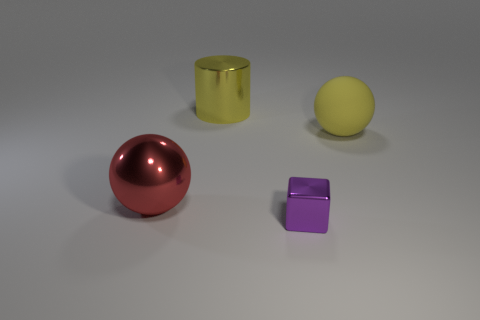Is there any other thing that is the same shape as the tiny purple thing?
Provide a succinct answer. No. What number of other objects are the same shape as the red metal thing?
Your answer should be compact. 1. Is there any other thing that has the same material as the small object?
Provide a succinct answer. Yes. The big object that is left of the small shiny block and in front of the cylinder is made of what material?
Your answer should be very brief. Metal. There is a small thing that is made of the same material as the big yellow cylinder; what shape is it?
Provide a succinct answer. Cube. Is there anything else that has the same color as the tiny cube?
Your answer should be compact. No. Is the number of large red spheres in front of the red thing greater than the number of metallic spheres?
Offer a terse response. No. What is the material of the red ball?
Your answer should be compact. Metal. What number of matte things have the same size as the purple block?
Ensure brevity in your answer.  0. Are there the same number of spheres behind the yellow shiny object and large spheres to the left of the yellow rubber thing?
Your response must be concise. No. 